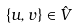Convert formula to latex. <formula><loc_0><loc_0><loc_500><loc_500>\{ u , v \} \in \hat { V }</formula> 